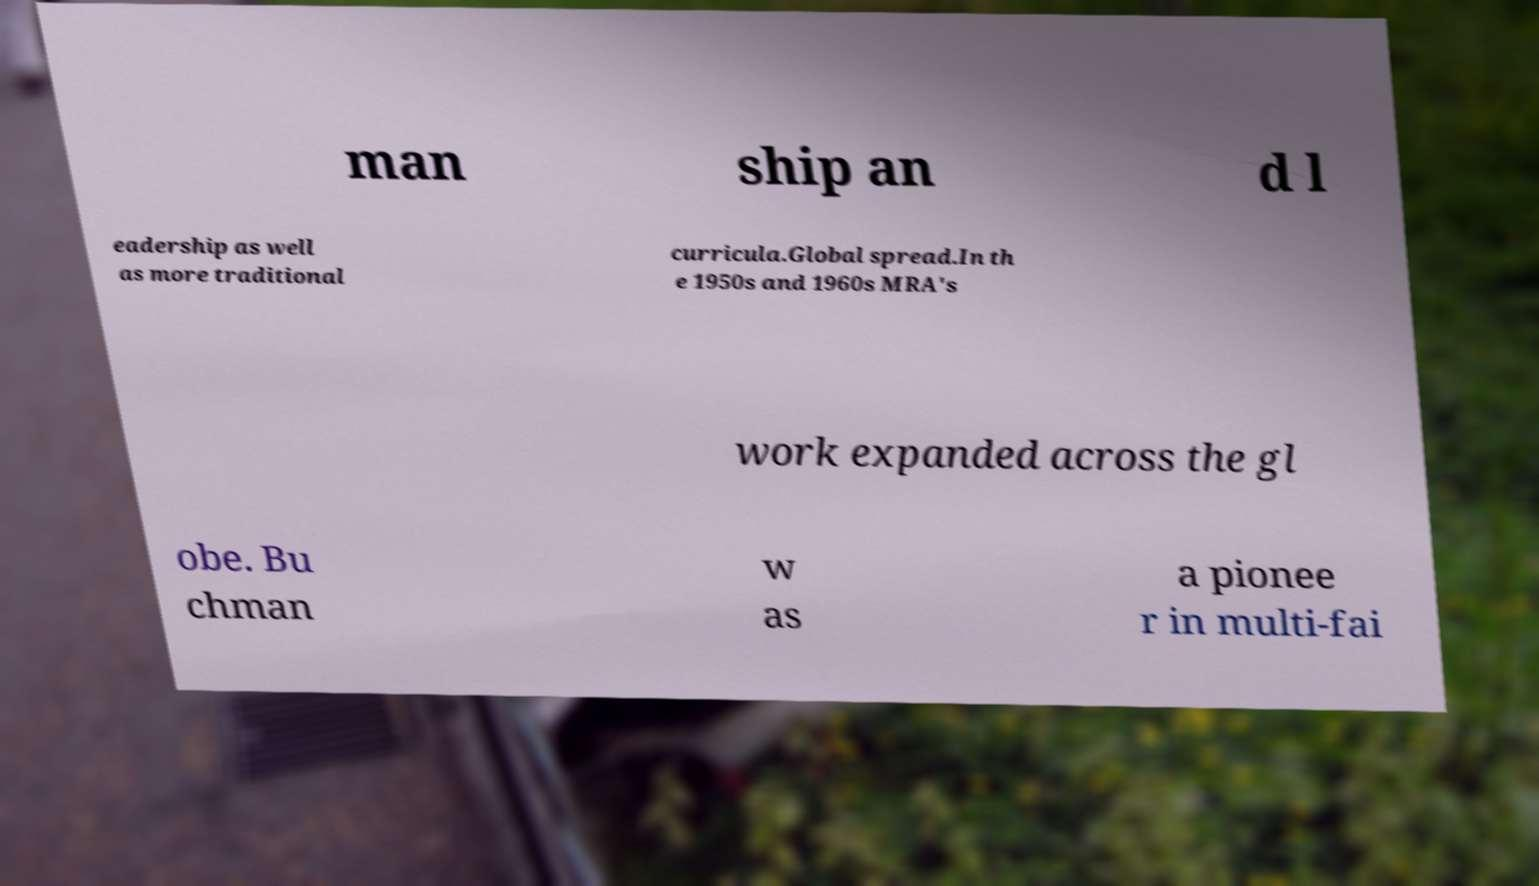Could you extract and type out the text from this image? man ship an d l eadership as well as more traditional curricula.Global spread.In th e 1950s and 1960s MRA's work expanded across the gl obe. Bu chman w as a pionee r in multi-fai 